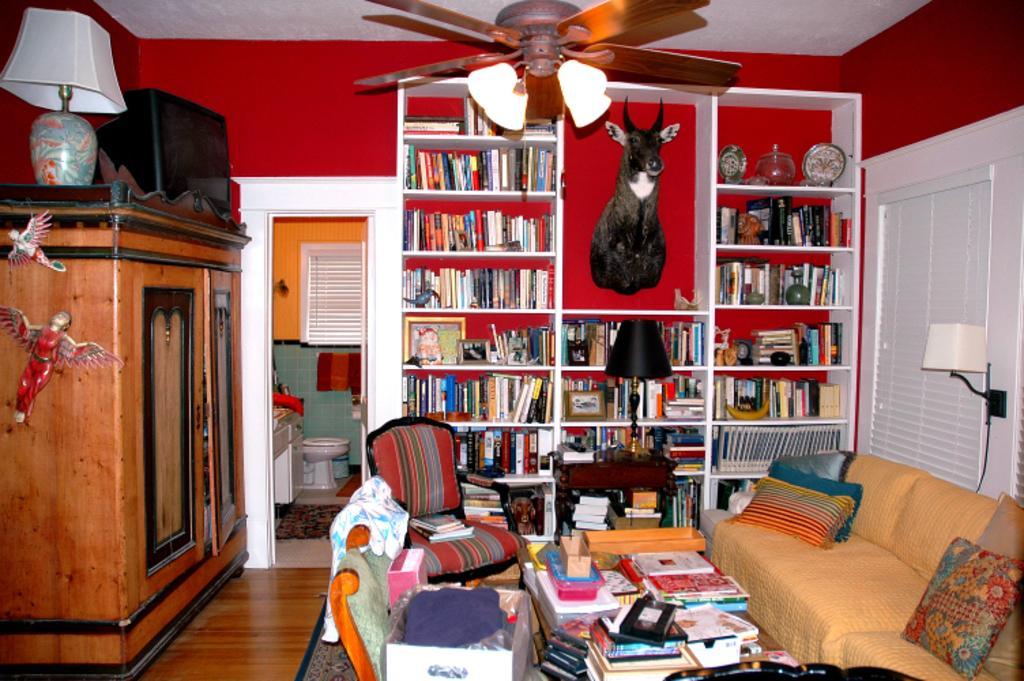Describe this image in one or two sentences. In this image I can see a bookshelf with so many books, at the top of the image I can see a fan. On the left hand side I can see a lamp with a wooden cupboard with some objects. In the center of the image I can see a way to the toilet I can see a toilet seat. On the right hand side of the image I can see a window with a lamp. At the bottom of the image I can see a sofa, a glass table, some books and other objects.  